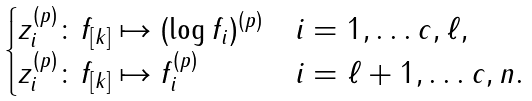Convert formula to latex. <formula><loc_0><loc_0><loc_500><loc_500>\begin{cases} z _ { i } ^ { ( p ) } \colon f _ { [ k ] } \mapsto ( \log f _ { i } ) ^ { ( p ) } & i = 1 , \dots c , \ell , \\ z _ { i } ^ { ( p ) } \colon f _ { [ k ] } \mapsto f _ { i } ^ { ( p ) } & i = \ell + 1 , \dots c , n . \end{cases}</formula> 